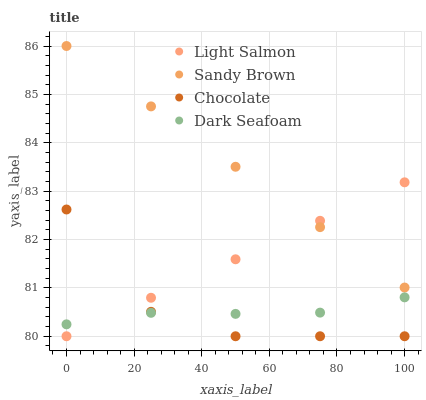Does Chocolate have the minimum area under the curve?
Answer yes or no. Yes. Does Sandy Brown have the maximum area under the curve?
Answer yes or no. Yes. Does Dark Seafoam have the minimum area under the curve?
Answer yes or no. No. Does Dark Seafoam have the maximum area under the curve?
Answer yes or no. No. Is Light Salmon the smoothest?
Answer yes or no. Yes. Is Chocolate the roughest?
Answer yes or no. Yes. Is Sandy Brown the smoothest?
Answer yes or no. No. Is Sandy Brown the roughest?
Answer yes or no. No. Does Light Salmon have the lowest value?
Answer yes or no. Yes. Does Dark Seafoam have the lowest value?
Answer yes or no. No. Does Sandy Brown have the highest value?
Answer yes or no. Yes. Does Dark Seafoam have the highest value?
Answer yes or no. No. Is Dark Seafoam less than Sandy Brown?
Answer yes or no. Yes. Is Sandy Brown greater than Dark Seafoam?
Answer yes or no. Yes. Does Light Salmon intersect Dark Seafoam?
Answer yes or no. Yes. Is Light Salmon less than Dark Seafoam?
Answer yes or no. No. Is Light Salmon greater than Dark Seafoam?
Answer yes or no. No. Does Dark Seafoam intersect Sandy Brown?
Answer yes or no. No. 